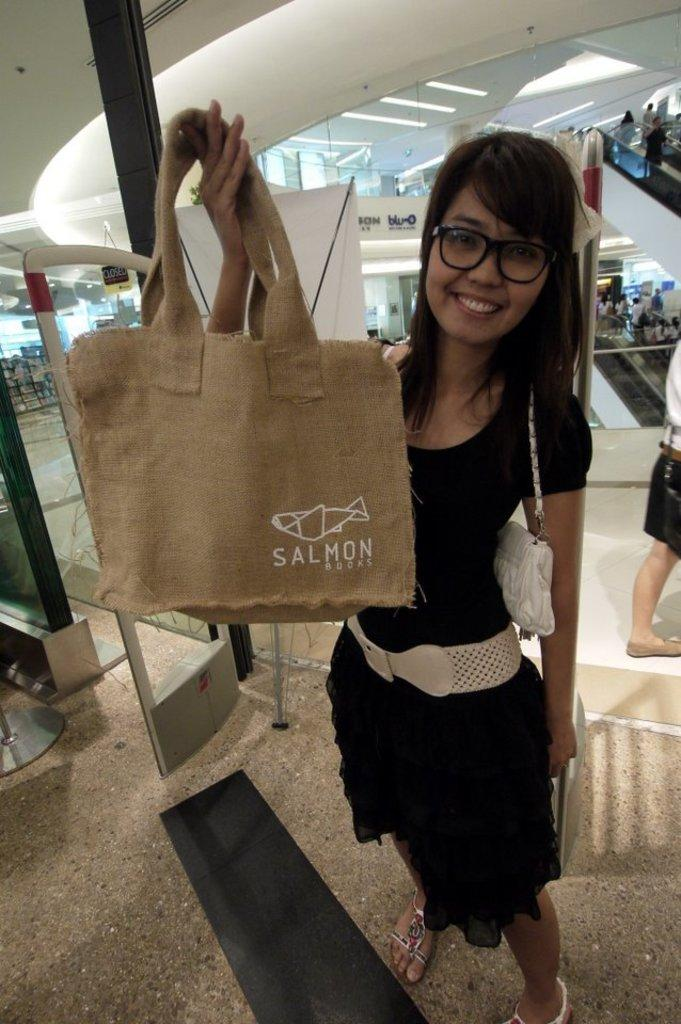Who is the main subject in the image? There is a woman in the image. What is the woman doing in the image? The woman is standing. What is the woman holding in the image? The woman is holding a jute bag. What is written on the jute bag? The word "Salmon" is written on the jute bag. Where are the scissors located in the image? There are no scissors present in the image. What type of list can be seen in the woman's stomach in the image? There is no list visible in the image, and the woman's stomach is not mentioned in the provided facts. 